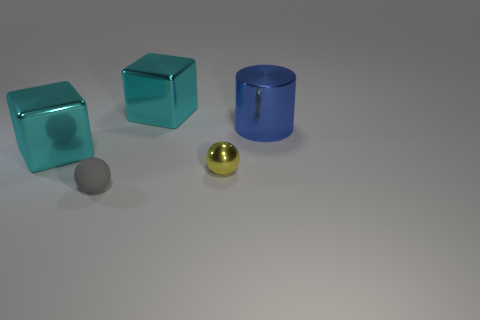Add 2 cylinders. How many objects exist? 7 Subtract all spheres. How many objects are left? 3 Subtract 0 cyan cylinders. How many objects are left? 5 Subtract all tiny cyan rubber cylinders. Subtract all big shiny cubes. How many objects are left? 3 Add 2 big objects. How many big objects are left? 5 Add 5 cylinders. How many cylinders exist? 6 